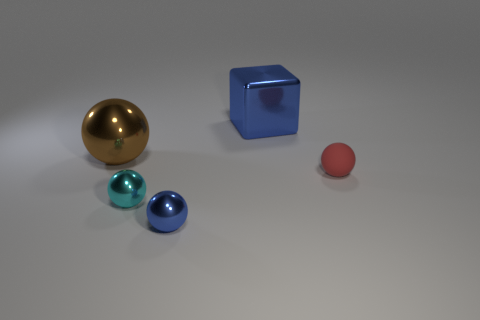How many large balls have the same color as the shiny block?
Offer a very short reply. 0. Do the big shiny sphere and the matte thing have the same color?
Provide a succinct answer. No. What is the cyan object that is in front of the brown metallic thing made of?
Provide a succinct answer. Metal. What number of tiny objects are either blue metallic blocks or red cubes?
Provide a succinct answer. 0. There is a tiny ball that is the same color as the big block; what material is it?
Offer a very short reply. Metal. Is there another tiny sphere made of the same material as the cyan sphere?
Offer a terse response. Yes. There is a blue object that is behind the cyan thing; is it the same size as the big ball?
Provide a succinct answer. Yes. There is a large object in front of the blue metallic thing on the right side of the small blue thing; is there a brown thing that is right of it?
Your answer should be compact. No. How many rubber objects are either gray spheres or brown balls?
Give a very brief answer. 0. What number of other things are the same shape as the tiny rubber object?
Ensure brevity in your answer.  3. 